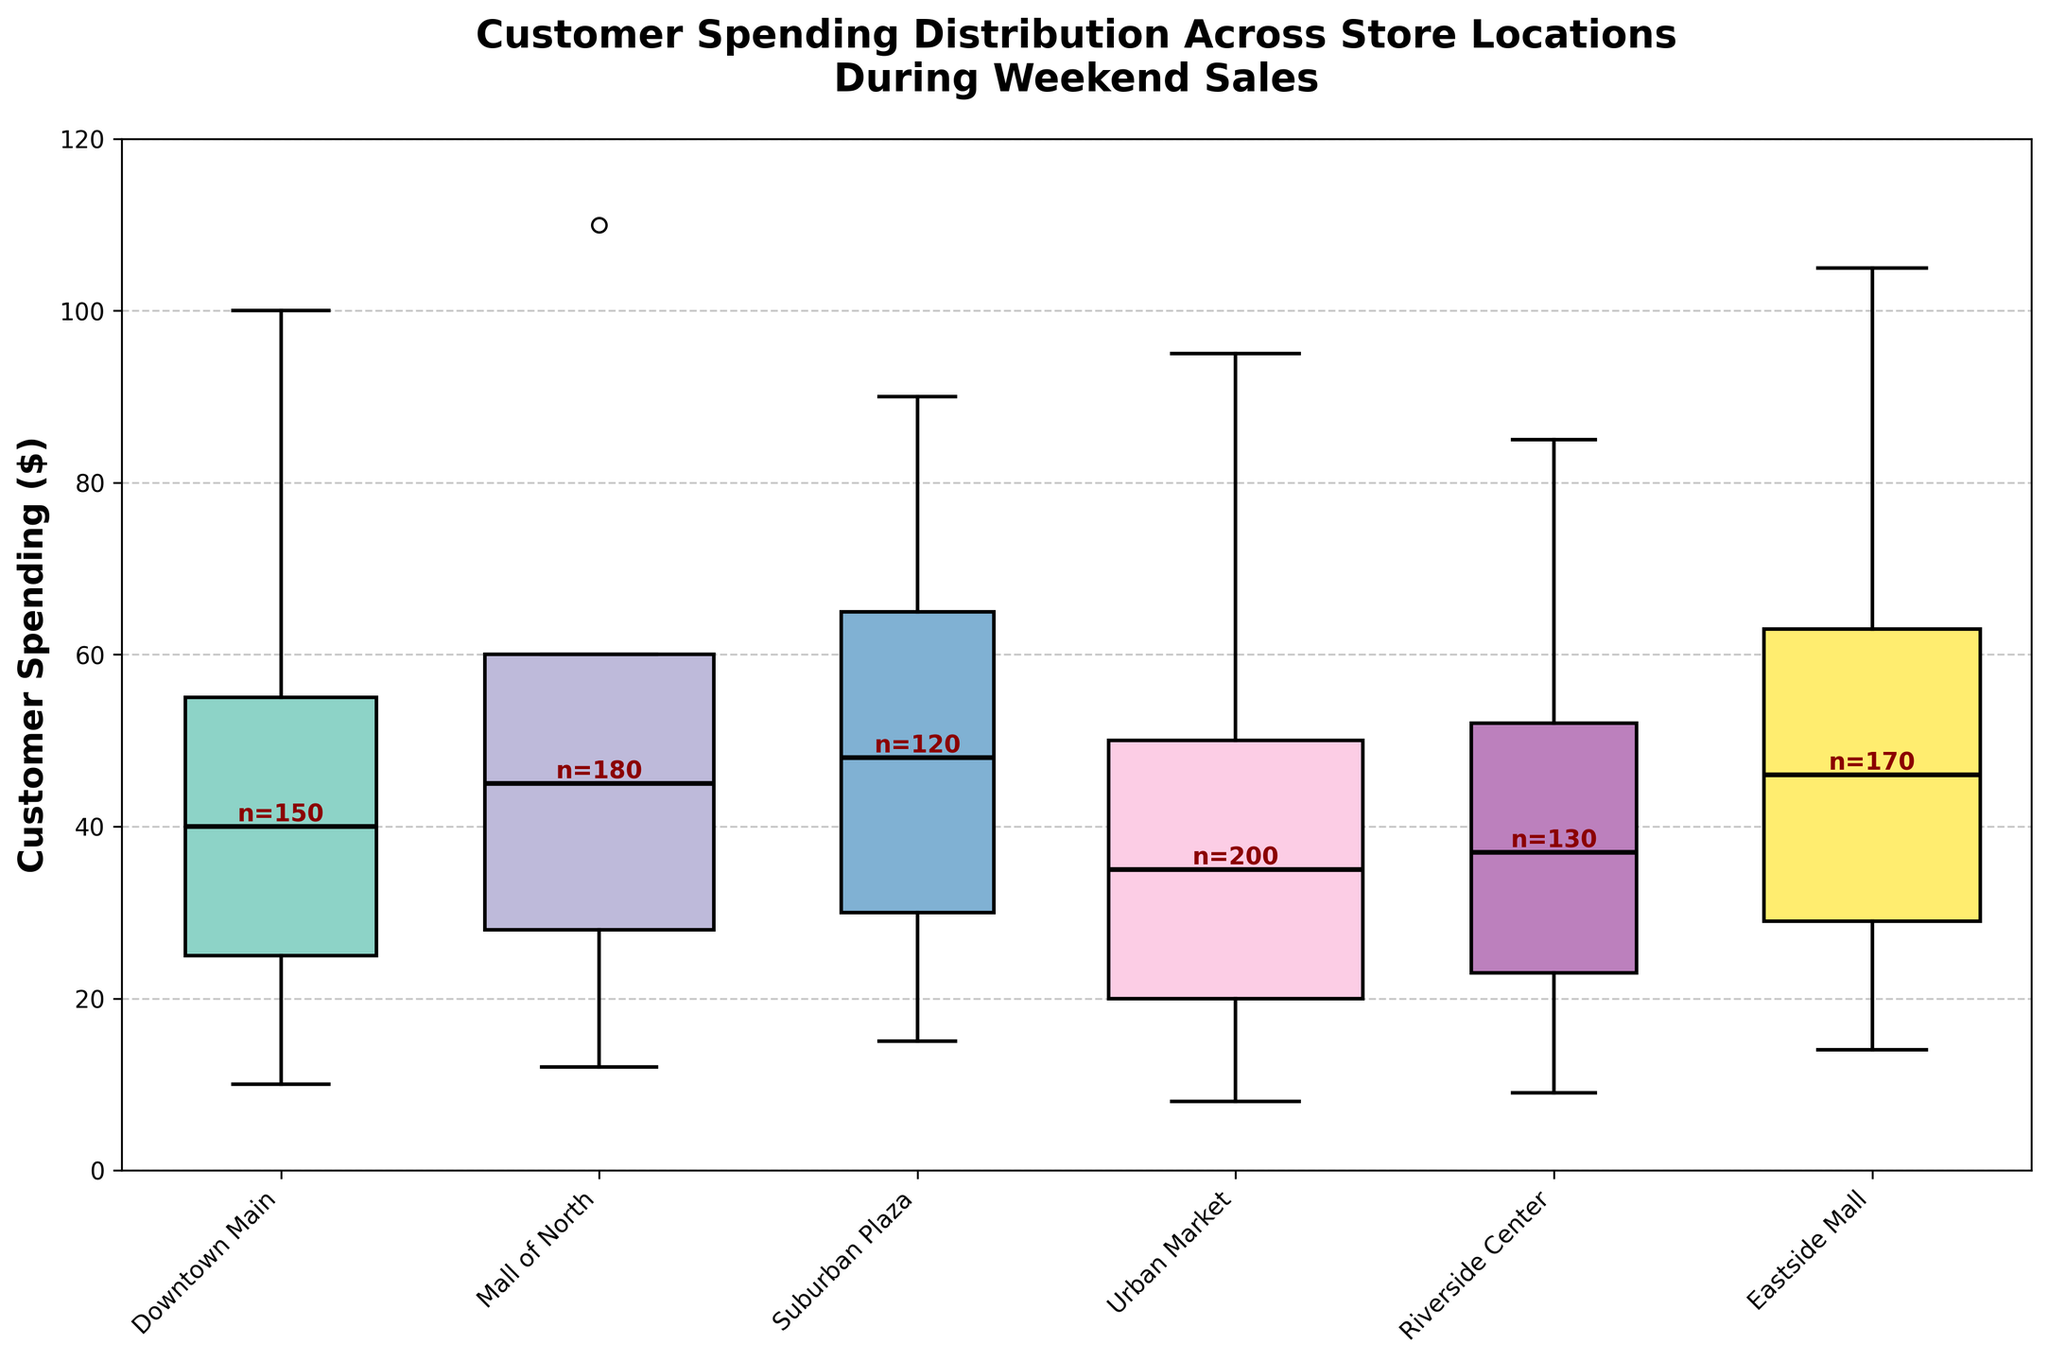What is the title of the plot? The title is located at the top of the plot. It provides a description of the data being visualized.
Answer: Customer Spending Distribution Across Store Locations During Weekend Sales Which store has the highest median spending? By looking at the horizontal lines inside boxes, which represent median spending, we can compare their positions.
Answer: Eastside Mall What is the range of spending for Urban Market? The range is calculated by subtracting the minimum spending from the maximum spending for Urban Market.
Answer: 87 ($95 - $8) Which store has the widest box plot? The width of the box plots represents the number of customers. By visually comparing the widths, we can determine the store with the widest box plot.
Answer: Urban Market Which store has the least variation in spending based on the interquartile range (IQR)? The IQR is the height of the box part of the box plot. We can compare the heights to see which is the smallest.
Answer: Riverside Center How does the median spending of Downtown Main compare to that of Mall of North? Identify the medians for both stores by looking at the horizontal lines inside the boxes and compare their values.
Answer: Downtown Main has a lower median spending ($40 vs. $45) What is the spending range for Mall of North? The spending range is the difference between the maximum and minimum spending for Mall of North.
Answer: 98 ($110 - $12) Which store has the most customers? The number of customers is indicated by the text labels near each box plot. Identify the largest number.
Answer: Urban Market How does the third quartile of Suburban Plaza compare to the third quartile of Eastside Mall? Identify the third quartile values for both Suburban Plaza and Eastside Mall by looking at the top edge of the boxes and compare them.
Answer: Suburban Plaza has a lower third quartile ($65 vs. $63) What is the spending pattern of Riverside Center compared to Urban Market? Compare the median, quartiles, and range of spending between Riverside Center and Urban Market by analyzing the positions and lengths of the box plot features for both.
Answer: Riverside Center has higher minimum ($9 vs. $8), first quartile ($23 vs. $20), median ($37 vs. $35), third quartile ($52 vs. $50) and lower maximum spending ($85 vs. $95) 